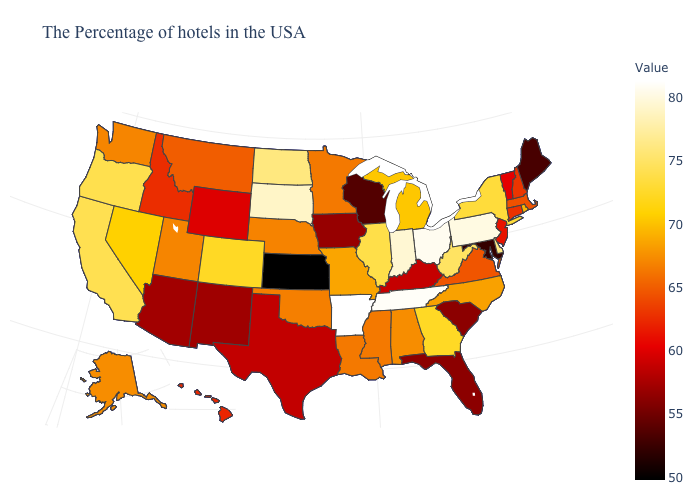Which states hav the highest value in the West?
Quick response, please. California. Does Arkansas have the highest value in the USA?
Short answer required. Yes. Which states hav the highest value in the West?
Give a very brief answer. California. Does Maryland have the lowest value in the USA?
Give a very brief answer. No. Among the states that border Utah , does Colorado have the highest value?
Quick response, please. Yes. Does the map have missing data?
Keep it brief. No. Does Vermont have the lowest value in the Northeast?
Give a very brief answer. No. Does the map have missing data?
Write a very short answer. No. 